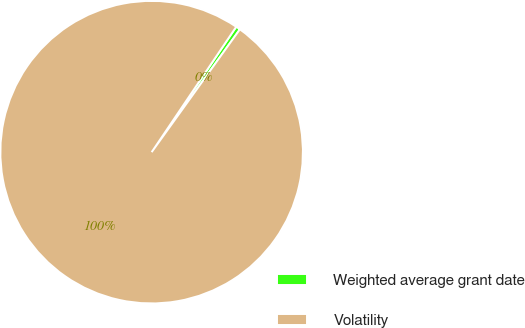Convert chart. <chart><loc_0><loc_0><loc_500><loc_500><pie_chart><fcel>Weighted average grant date<fcel>Volatility<nl><fcel>0.47%<fcel>99.53%<nl></chart> 